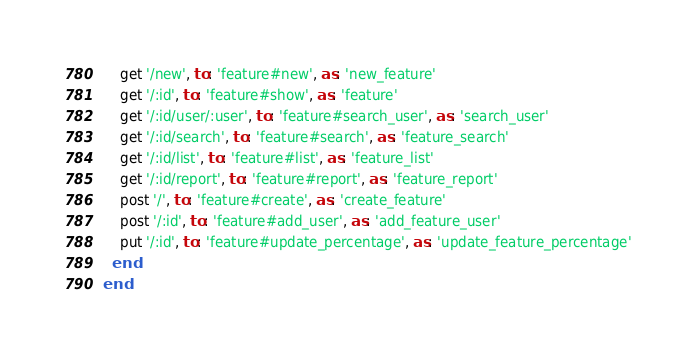Convert code to text. <code><loc_0><loc_0><loc_500><loc_500><_Ruby_>    get '/new', to: 'feature#new', as: 'new_feature'
    get '/:id', to: 'feature#show', as: 'feature'
    get '/:id/user/:user', to: 'feature#search_user', as: 'search_user'
    get '/:id/search', to: 'feature#search', as: 'feature_search'
    get '/:id/list', to: 'feature#list', as: 'feature_list'
    get '/:id/report', to: 'feature#report', as: 'feature_report'
    post '/', to: 'feature#create', as: 'create_feature'
    post '/:id', to: 'feature#add_user', as: 'add_feature_user'
    put '/:id', to: 'feature#update_percentage', as: 'update_feature_percentage'
  end
end
</code> 